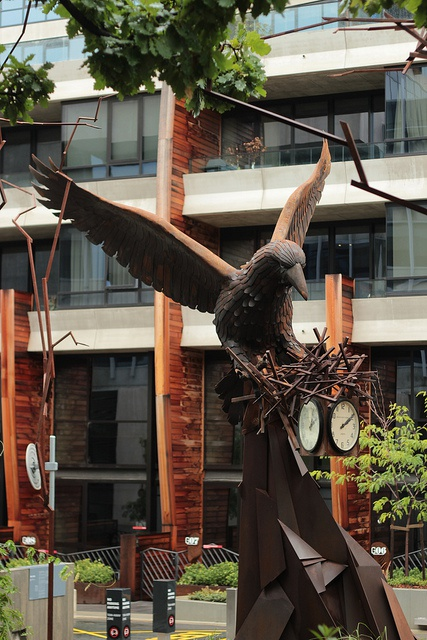Describe the objects in this image and their specific colors. I can see bird in maroon, black, and gray tones, clock in maroon, black, and tan tones, and clock in maroon, darkgray, beige, gray, and lightgray tones in this image. 